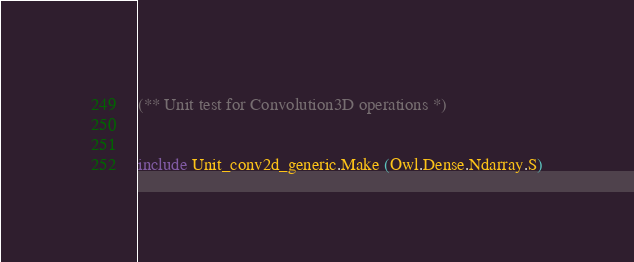<code> <loc_0><loc_0><loc_500><loc_500><_OCaml_>(** Unit test for Convolution3D operations *)


include Unit_conv2d_generic.Make (Owl.Dense.Ndarray.S)
</code> 